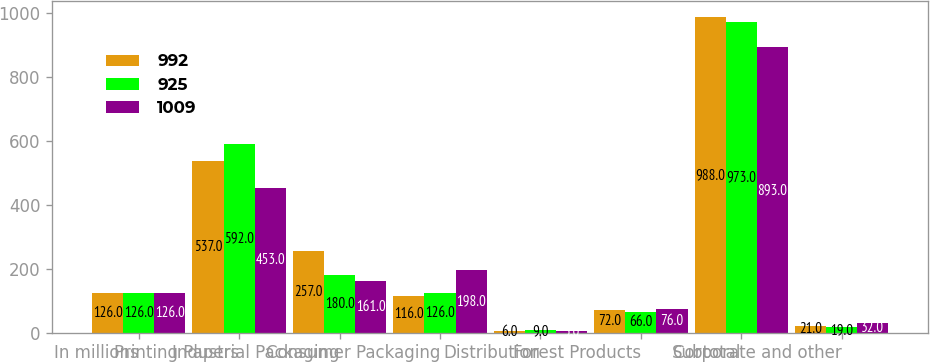Convert chart to OTSL. <chart><loc_0><loc_0><loc_500><loc_500><stacked_bar_chart><ecel><fcel>In millions<fcel>Printing Papers<fcel>Industrial Packaging<fcel>Consumer Packaging<fcel>Distribution<fcel>Forest Products<fcel>Subtotal<fcel>Corporate and other<nl><fcel>992<fcel>126<fcel>537<fcel>257<fcel>116<fcel>6<fcel>72<fcel>988<fcel>21<nl><fcel>925<fcel>126<fcel>592<fcel>180<fcel>126<fcel>9<fcel>66<fcel>973<fcel>19<nl><fcel>1009<fcel>126<fcel>453<fcel>161<fcel>198<fcel>5<fcel>76<fcel>893<fcel>32<nl></chart> 